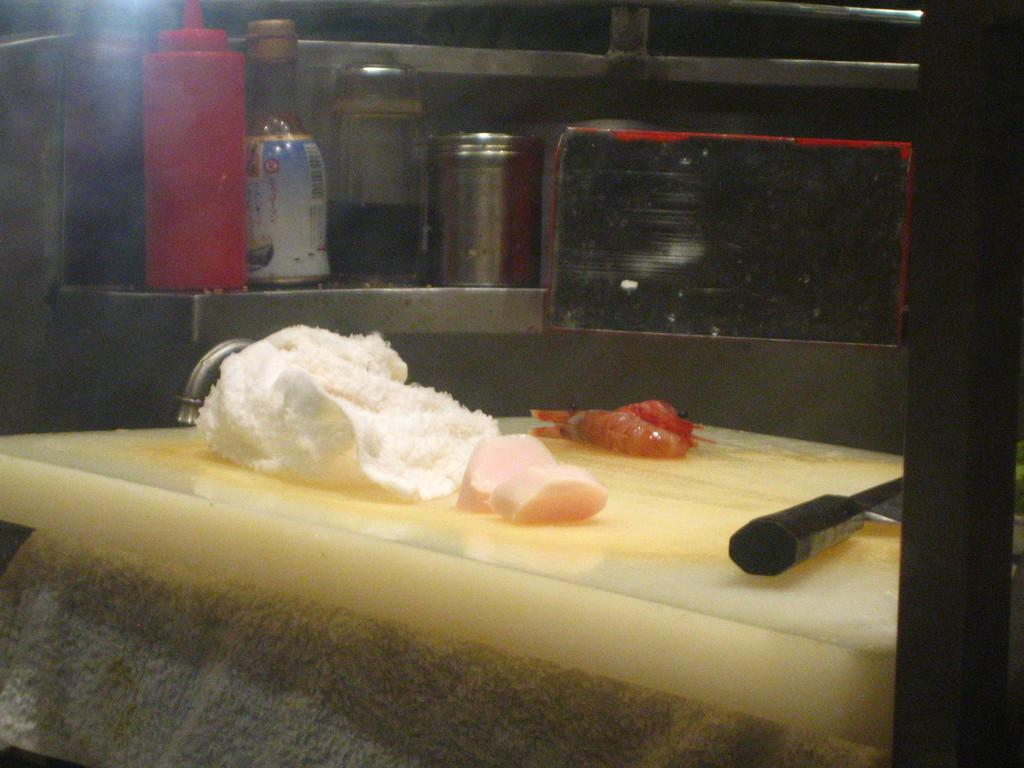What type of utensil is present in the image? There is a knife in the image. What type of food is visible in the image? There is meat in the image. What type of container is present in the image? There is a bottle and a sauce bottle in the image. What type of packaging is present in the image? There is a box in the image. What type of dishware is present in the image? There is a plate in the image. What type of cave is depicted in the image? There is no cave present in the image. What type of learning materials can be seen in the image? There are no learning materials present in the image. 